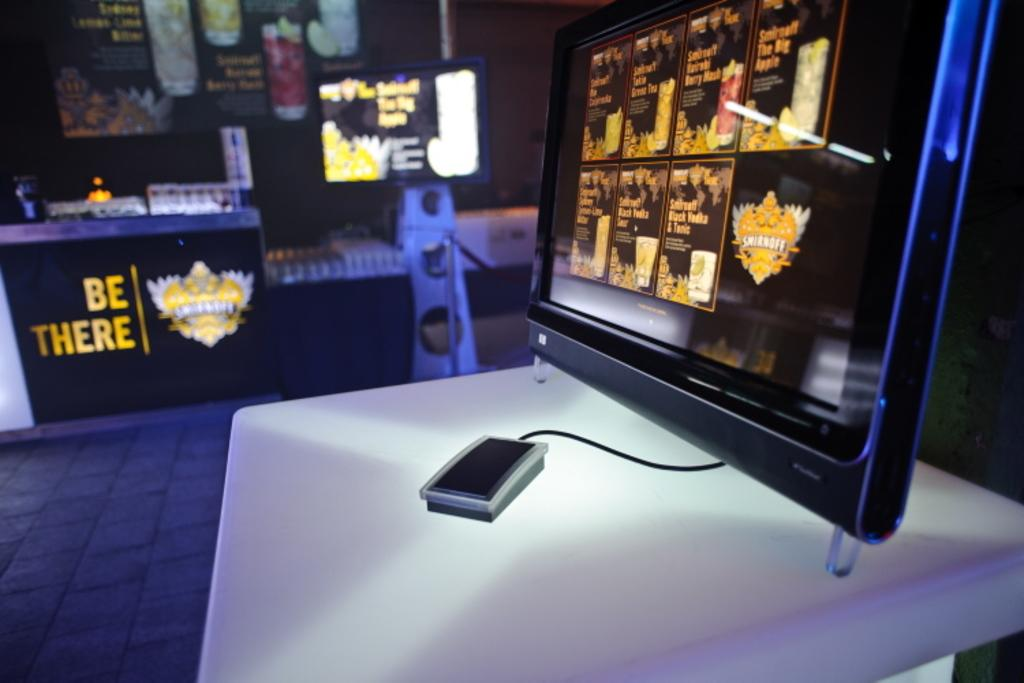<image>
Summarize the visual content of the image. A mouse is tethered to a computer monitor which sits on a table displaying be there. 